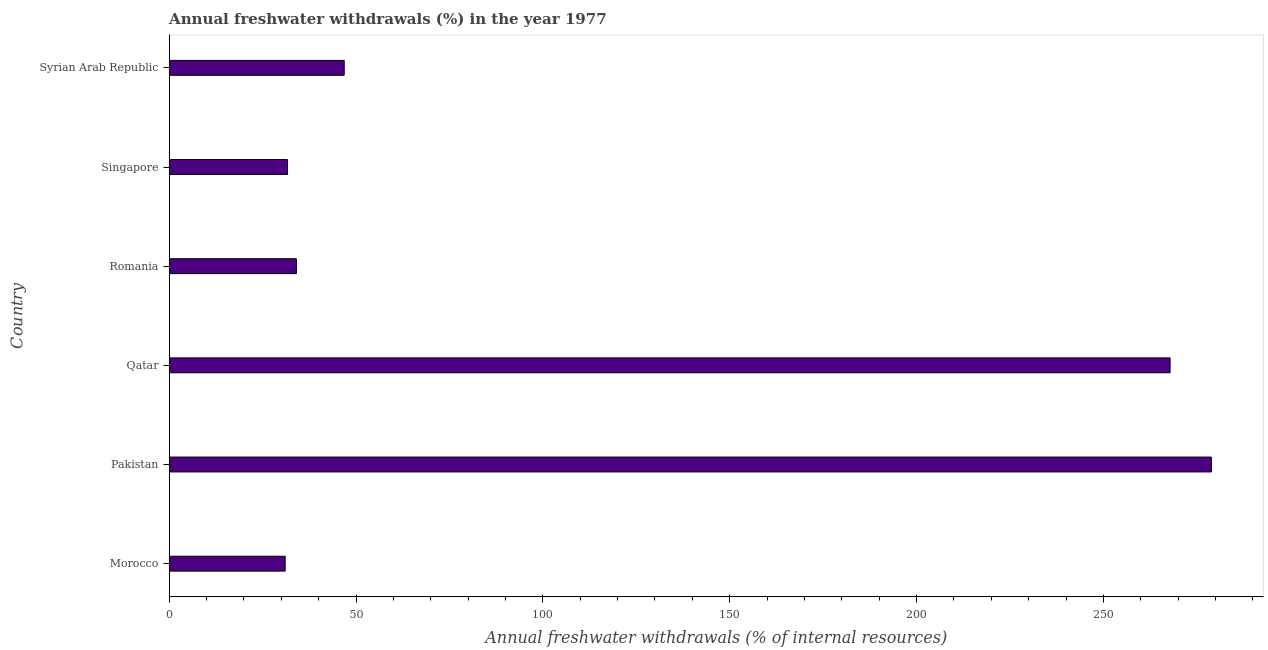What is the title of the graph?
Provide a short and direct response. Annual freshwater withdrawals (%) in the year 1977. What is the label or title of the X-axis?
Offer a very short reply. Annual freshwater withdrawals (% of internal resources). What is the label or title of the Y-axis?
Offer a very short reply. Country. What is the annual freshwater withdrawals in Morocco?
Your response must be concise. 31.03. Across all countries, what is the maximum annual freshwater withdrawals?
Your answer should be compact. 278.91. Across all countries, what is the minimum annual freshwater withdrawals?
Offer a terse response. 31.03. In which country was the annual freshwater withdrawals minimum?
Offer a terse response. Morocco. What is the sum of the annual freshwater withdrawals?
Offer a terse response. 690.34. What is the difference between the annual freshwater withdrawals in Morocco and Singapore?
Provide a succinct answer. -0.63. What is the average annual freshwater withdrawals per country?
Provide a short and direct response. 115.06. What is the median annual freshwater withdrawals?
Offer a terse response. 40.44. In how many countries, is the annual freshwater withdrawals greater than 190 %?
Offer a very short reply. 2. What is the ratio of the annual freshwater withdrawals in Romania to that in Syrian Arab Republic?
Offer a terse response. 0.73. Is the difference between the annual freshwater withdrawals in Pakistan and Romania greater than the difference between any two countries?
Make the answer very short. No. What is the difference between the highest and the second highest annual freshwater withdrawals?
Give a very brief answer. 11.05. What is the difference between the highest and the lowest annual freshwater withdrawals?
Ensure brevity in your answer.  247.87. What is the Annual freshwater withdrawals (% of internal resources) in Morocco?
Keep it short and to the point. 31.03. What is the Annual freshwater withdrawals (% of internal resources) in Pakistan?
Offer a terse response. 278.91. What is the Annual freshwater withdrawals (% of internal resources) of Qatar?
Your answer should be very brief. 267.86. What is the Annual freshwater withdrawals (% of internal resources) of Romania?
Provide a succinct answer. 34.04. What is the Annual freshwater withdrawals (% of internal resources) in Singapore?
Give a very brief answer. 31.67. What is the Annual freshwater withdrawals (% of internal resources) of Syrian Arab Republic?
Offer a very short reply. 46.83. What is the difference between the Annual freshwater withdrawals (% of internal resources) in Morocco and Pakistan?
Keep it short and to the point. -247.87. What is the difference between the Annual freshwater withdrawals (% of internal resources) in Morocco and Qatar?
Keep it short and to the point. -236.82. What is the difference between the Annual freshwater withdrawals (% of internal resources) in Morocco and Romania?
Your response must be concise. -3.01. What is the difference between the Annual freshwater withdrawals (% of internal resources) in Morocco and Singapore?
Offer a terse response. -0.63. What is the difference between the Annual freshwater withdrawals (% of internal resources) in Morocco and Syrian Arab Republic?
Your response must be concise. -15.8. What is the difference between the Annual freshwater withdrawals (% of internal resources) in Pakistan and Qatar?
Provide a succinct answer. 11.05. What is the difference between the Annual freshwater withdrawals (% of internal resources) in Pakistan and Romania?
Your response must be concise. 244.87. What is the difference between the Annual freshwater withdrawals (% of internal resources) in Pakistan and Singapore?
Offer a very short reply. 247.24. What is the difference between the Annual freshwater withdrawals (% of internal resources) in Pakistan and Syrian Arab Republic?
Offer a very short reply. 232.08. What is the difference between the Annual freshwater withdrawals (% of internal resources) in Qatar and Romania?
Your response must be concise. 233.81. What is the difference between the Annual freshwater withdrawals (% of internal resources) in Qatar and Singapore?
Your answer should be very brief. 236.19. What is the difference between the Annual freshwater withdrawals (% of internal resources) in Qatar and Syrian Arab Republic?
Ensure brevity in your answer.  221.03. What is the difference between the Annual freshwater withdrawals (% of internal resources) in Romania and Singapore?
Make the answer very short. 2.38. What is the difference between the Annual freshwater withdrawals (% of internal resources) in Romania and Syrian Arab Republic?
Offer a terse response. -12.79. What is the difference between the Annual freshwater withdrawals (% of internal resources) in Singapore and Syrian Arab Republic?
Your response must be concise. -15.16. What is the ratio of the Annual freshwater withdrawals (% of internal resources) in Morocco to that in Pakistan?
Provide a succinct answer. 0.11. What is the ratio of the Annual freshwater withdrawals (% of internal resources) in Morocco to that in Qatar?
Make the answer very short. 0.12. What is the ratio of the Annual freshwater withdrawals (% of internal resources) in Morocco to that in Romania?
Your answer should be compact. 0.91. What is the ratio of the Annual freshwater withdrawals (% of internal resources) in Morocco to that in Singapore?
Offer a very short reply. 0.98. What is the ratio of the Annual freshwater withdrawals (% of internal resources) in Morocco to that in Syrian Arab Republic?
Your response must be concise. 0.66. What is the ratio of the Annual freshwater withdrawals (% of internal resources) in Pakistan to that in Qatar?
Your answer should be compact. 1.04. What is the ratio of the Annual freshwater withdrawals (% of internal resources) in Pakistan to that in Romania?
Ensure brevity in your answer.  8.19. What is the ratio of the Annual freshwater withdrawals (% of internal resources) in Pakistan to that in Singapore?
Your response must be concise. 8.81. What is the ratio of the Annual freshwater withdrawals (% of internal resources) in Pakistan to that in Syrian Arab Republic?
Keep it short and to the point. 5.96. What is the ratio of the Annual freshwater withdrawals (% of internal resources) in Qatar to that in Romania?
Provide a short and direct response. 7.87. What is the ratio of the Annual freshwater withdrawals (% of internal resources) in Qatar to that in Singapore?
Provide a short and direct response. 8.46. What is the ratio of the Annual freshwater withdrawals (% of internal resources) in Qatar to that in Syrian Arab Republic?
Ensure brevity in your answer.  5.72. What is the ratio of the Annual freshwater withdrawals (% of internal resources) in Romania to that in Singapore?
Give a very brief answer. 1.07. What is the ratio of the Annual freshwater withdrawals (% of internal resources) in Romania to that in Syrian Arab Republic?
Your response must be concise. 0.73. What is the ratio of the Annual freshwater withdrawals (% of internal resources) in Singapore to that in Syrian Arab Republic?
Offer a very short reply. 0.68. 